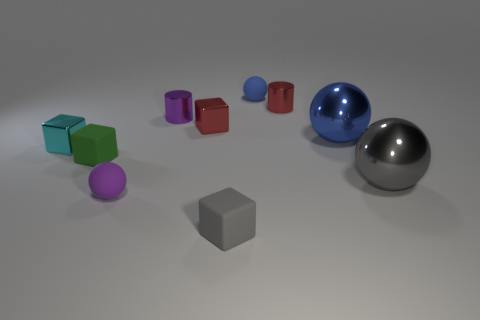How many tiny objects are to the right of the small blue thing and in front of the red shiny block?
Ensure brevity in your answer.  0. There is a blue object to the right of the red cylinder; how many big blue objects are left of it?
Your answer should be very brief. 0. How many things are red shiny objects that are on the left side of the tiny gray matte thing or gray shiny balls in front of the big blue shiny sphere?
Offer a very short reply. 2. There is another object that is the same shape as the purple shiny thing; what material is it?
Provide a short and direct response. Metal. What number of things are things that are left of the small blue sphere or small cyan metallic blocks?
Your answer should be compact. 6. What shape is the small cyan thing that is the same material as the big gray ball?
Give a very brief answer. Cube. What number of small blue rubber things have the same shape as the small gray rubber thing?
Keep it short and to the point. 0. What material is the gray sphere?
Provide a succinct answer. Metal. What number of balls are either tiny yellow matte things or metal objects?
Provide a succinct answer. 2. What is the color of the big ball that is to the left of the large gray thing?
Provide a succinct answer. Blue. 